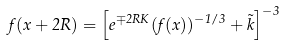Convert formula to latex. <formula><loc_0><loc_0><loc_500><loc_500>f ( x + 2 R ) = \left [ e ^ { \mp 2 R K } ( f ( x ) ) ^ { - 1 / 3 } + \tilde { k } \right ] ^ { - 3 }</formula> 